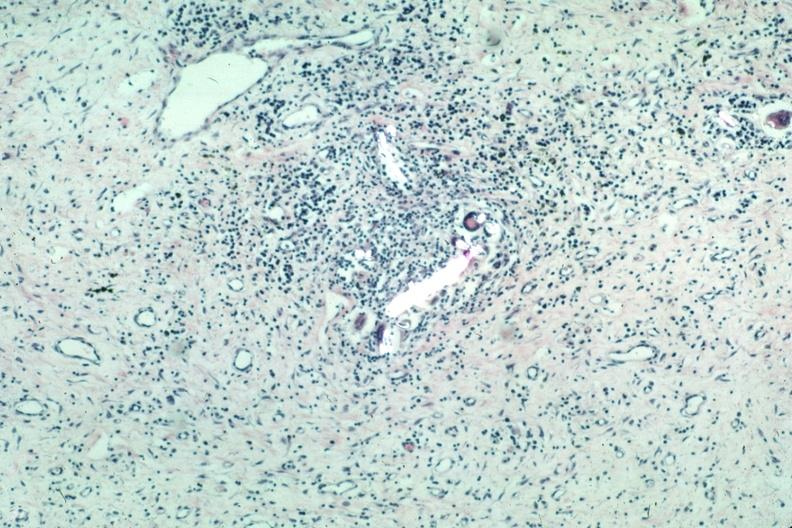does optic nerve show with partially crossed polarizing to show foreign material very typical?
Answer the question using a single word or phrase. No 